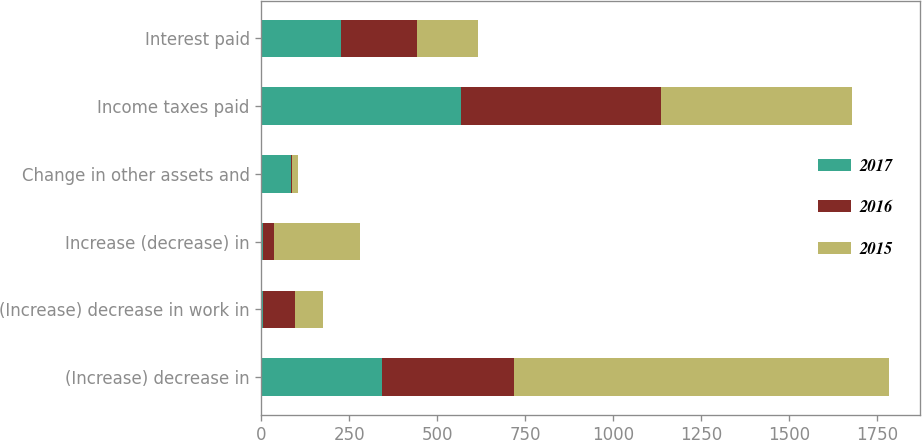Convert chart. <chart><loc_0><loc_0><loc_500><loc_500><stacked_bar_chart><ecel><fcel>(Increase) decrease in<fcel>(Increase) decrease in work in<fcel>Increase (decrease) in<fcel>Change in other assets and<fcel>Income taxes paid<fcel>Interest paid<nl><fcel>2017<fcel>341.6<fcel>5.4<fcel>4.8<fcel>83.3<fcel>566<fcel>226.2<nl><fcel>2016<fcel>376.5<fcel>89.7<fcel>31.6<fcel>4.5<fcel>570.4<fcel>216.7<nl><fcel>2015<fcel>1063.6<fcel>79.6<fcel>243.9<fcel>15.1<fcel>540.1<fcel>173.9<nl></chart> 